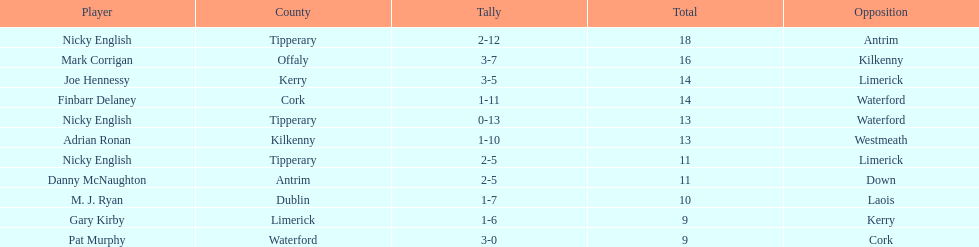What is the least total on the list? 9. 